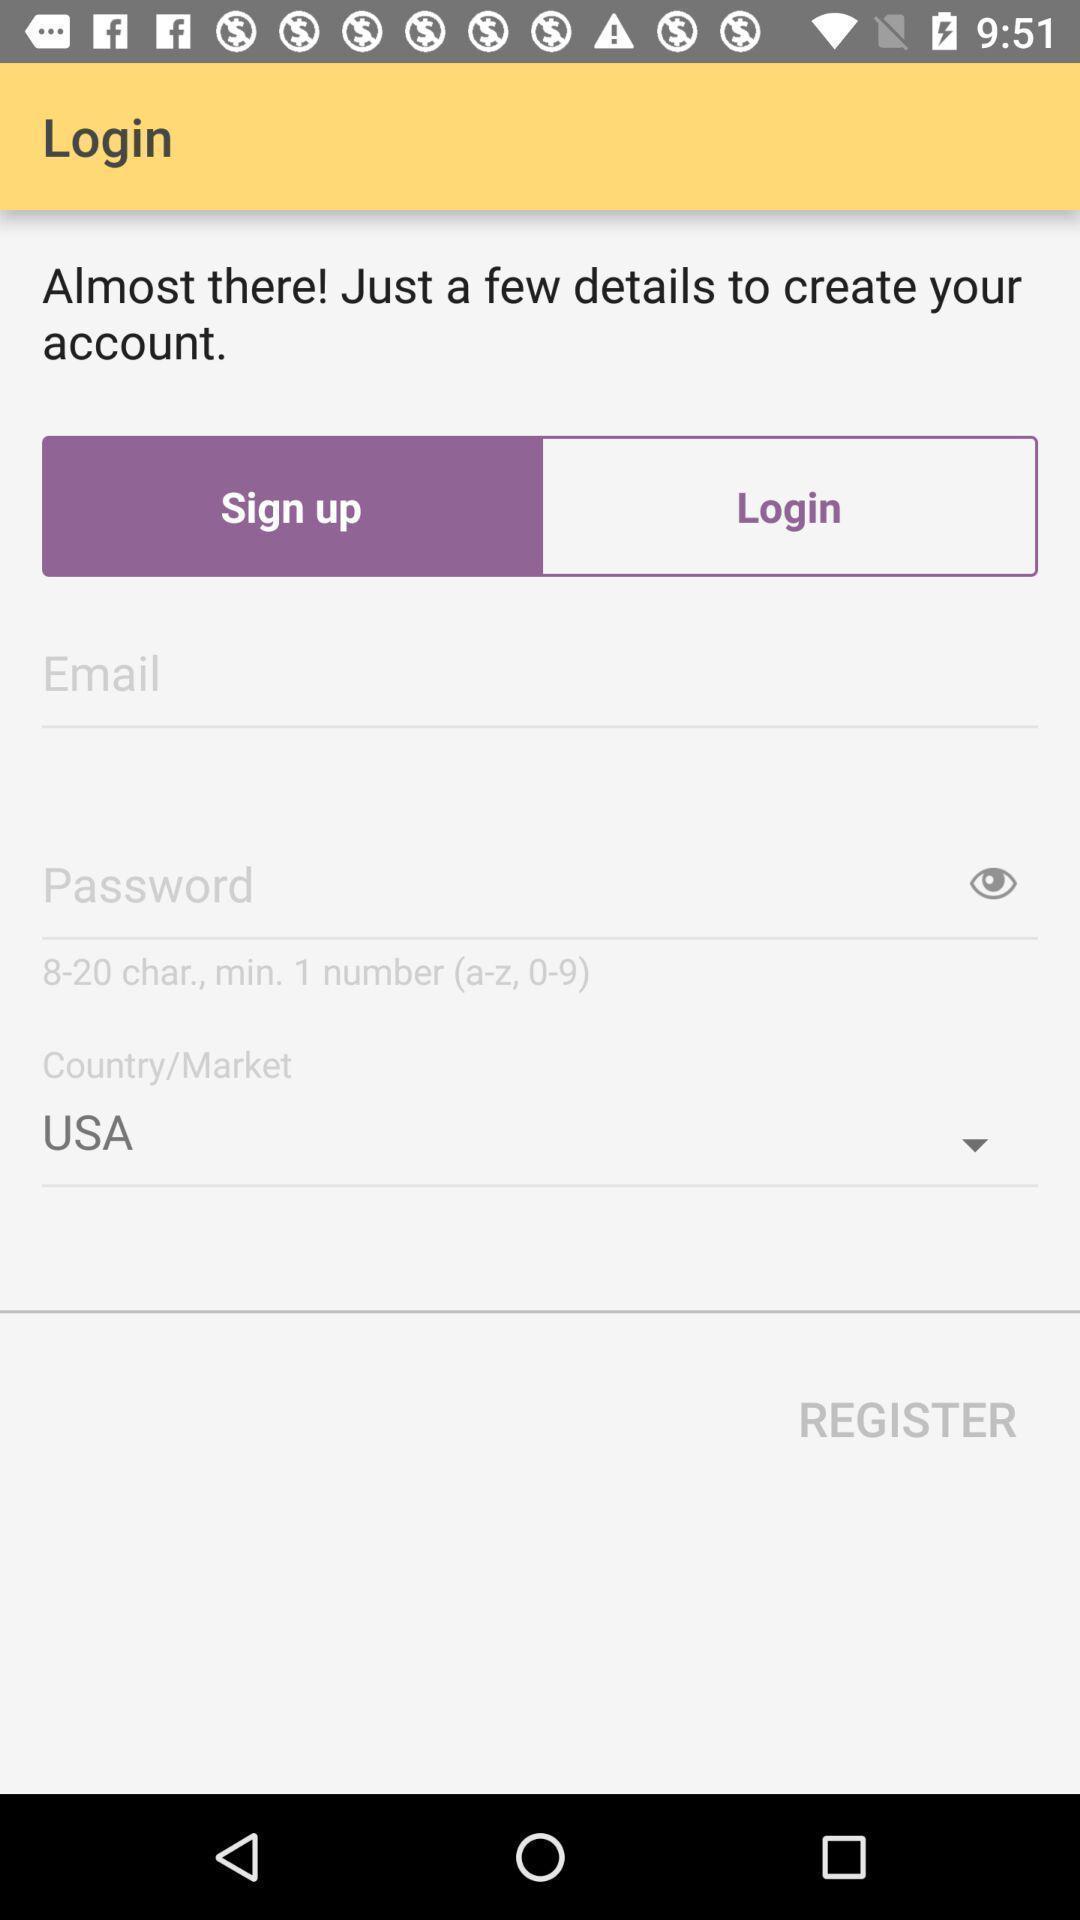Give me a narrative description of this picture. Sign up page. 